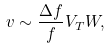<formula> <loc_0><loc_0><loc_500><loc_500>v \sim \frac { \Delta f } { f } V _ { T } W ,</formula> 